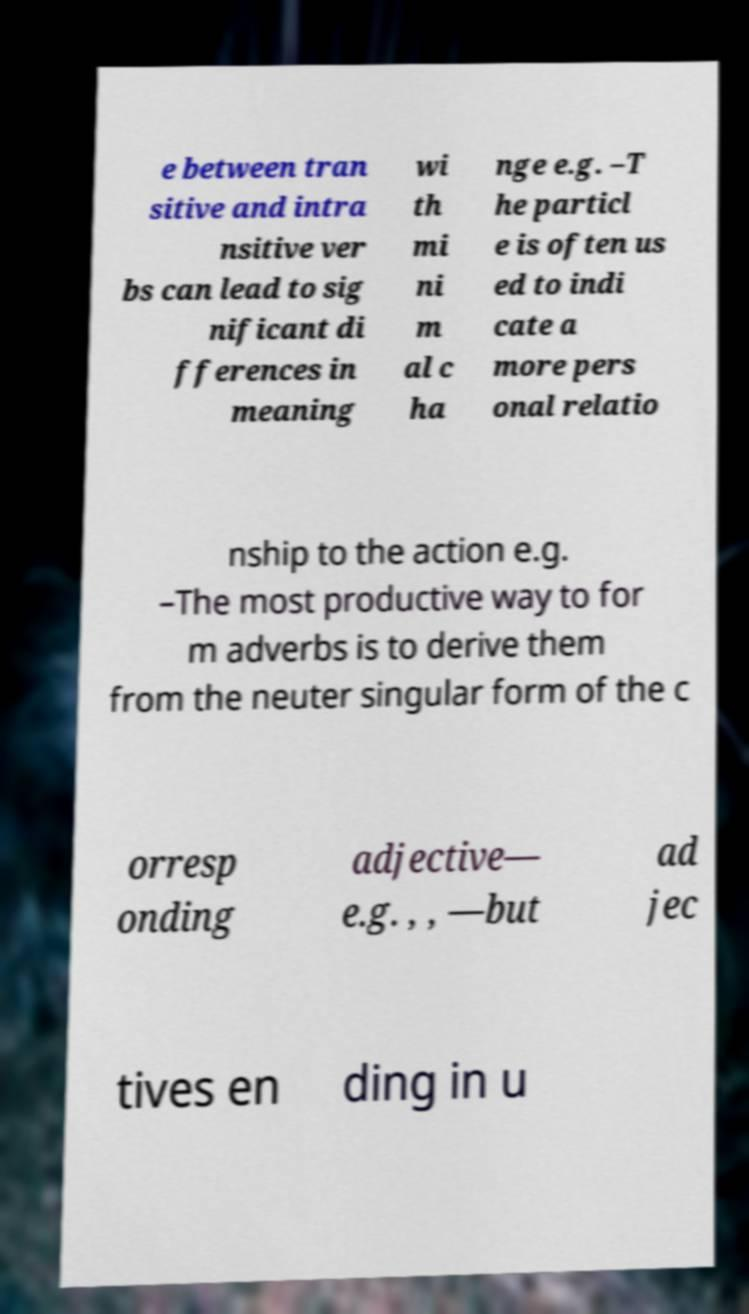Could you extract and type out the text from this image? e between tran sitive and intra nsitive ver bs can lead to sig nificant di fferences in meaning wi th mi ni m al c ha nge e.g. –T he particl e is often us ed to indi cate a more pers onal relatio nship to the action e.g. –The most productive way to for m adverbs is to derive them from the neuter singular form of the c orresp onding adjective— e.g. , , —but ad jec tives en ding in u 